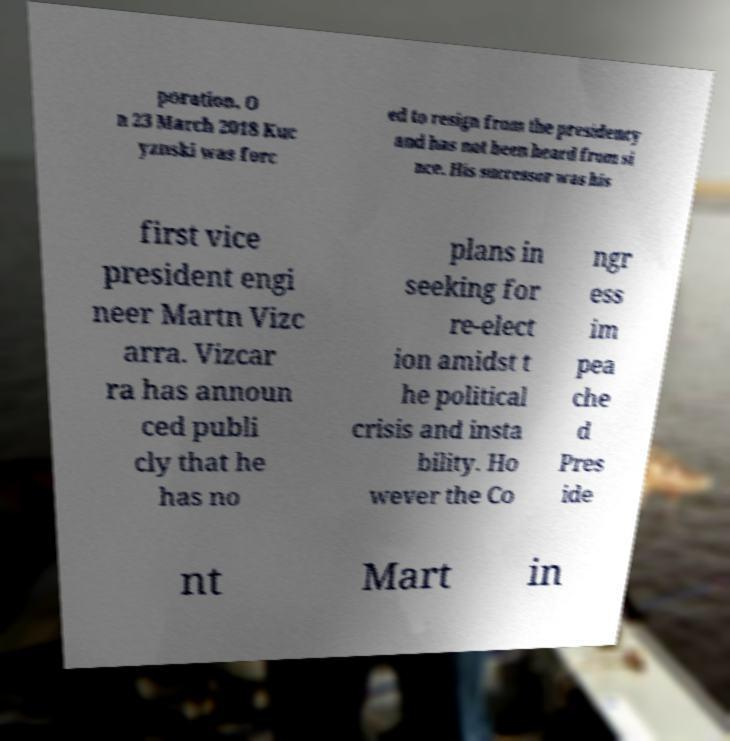Please identify and transcribe the text found in this image. poration. O n 23 March 2018 Kuc yznski was forc ed to resign from the presidency and has not been heard from si nce. His successor was his first vice president engi neer Martn Vizc arra. Vizcar ra has announ ced publi cly that he has no plans in seeking for re-elect ion amidst t he political crisis and insta bility. Ho wever the Co ngr ess im pea che d Pres ide nt Mart in 